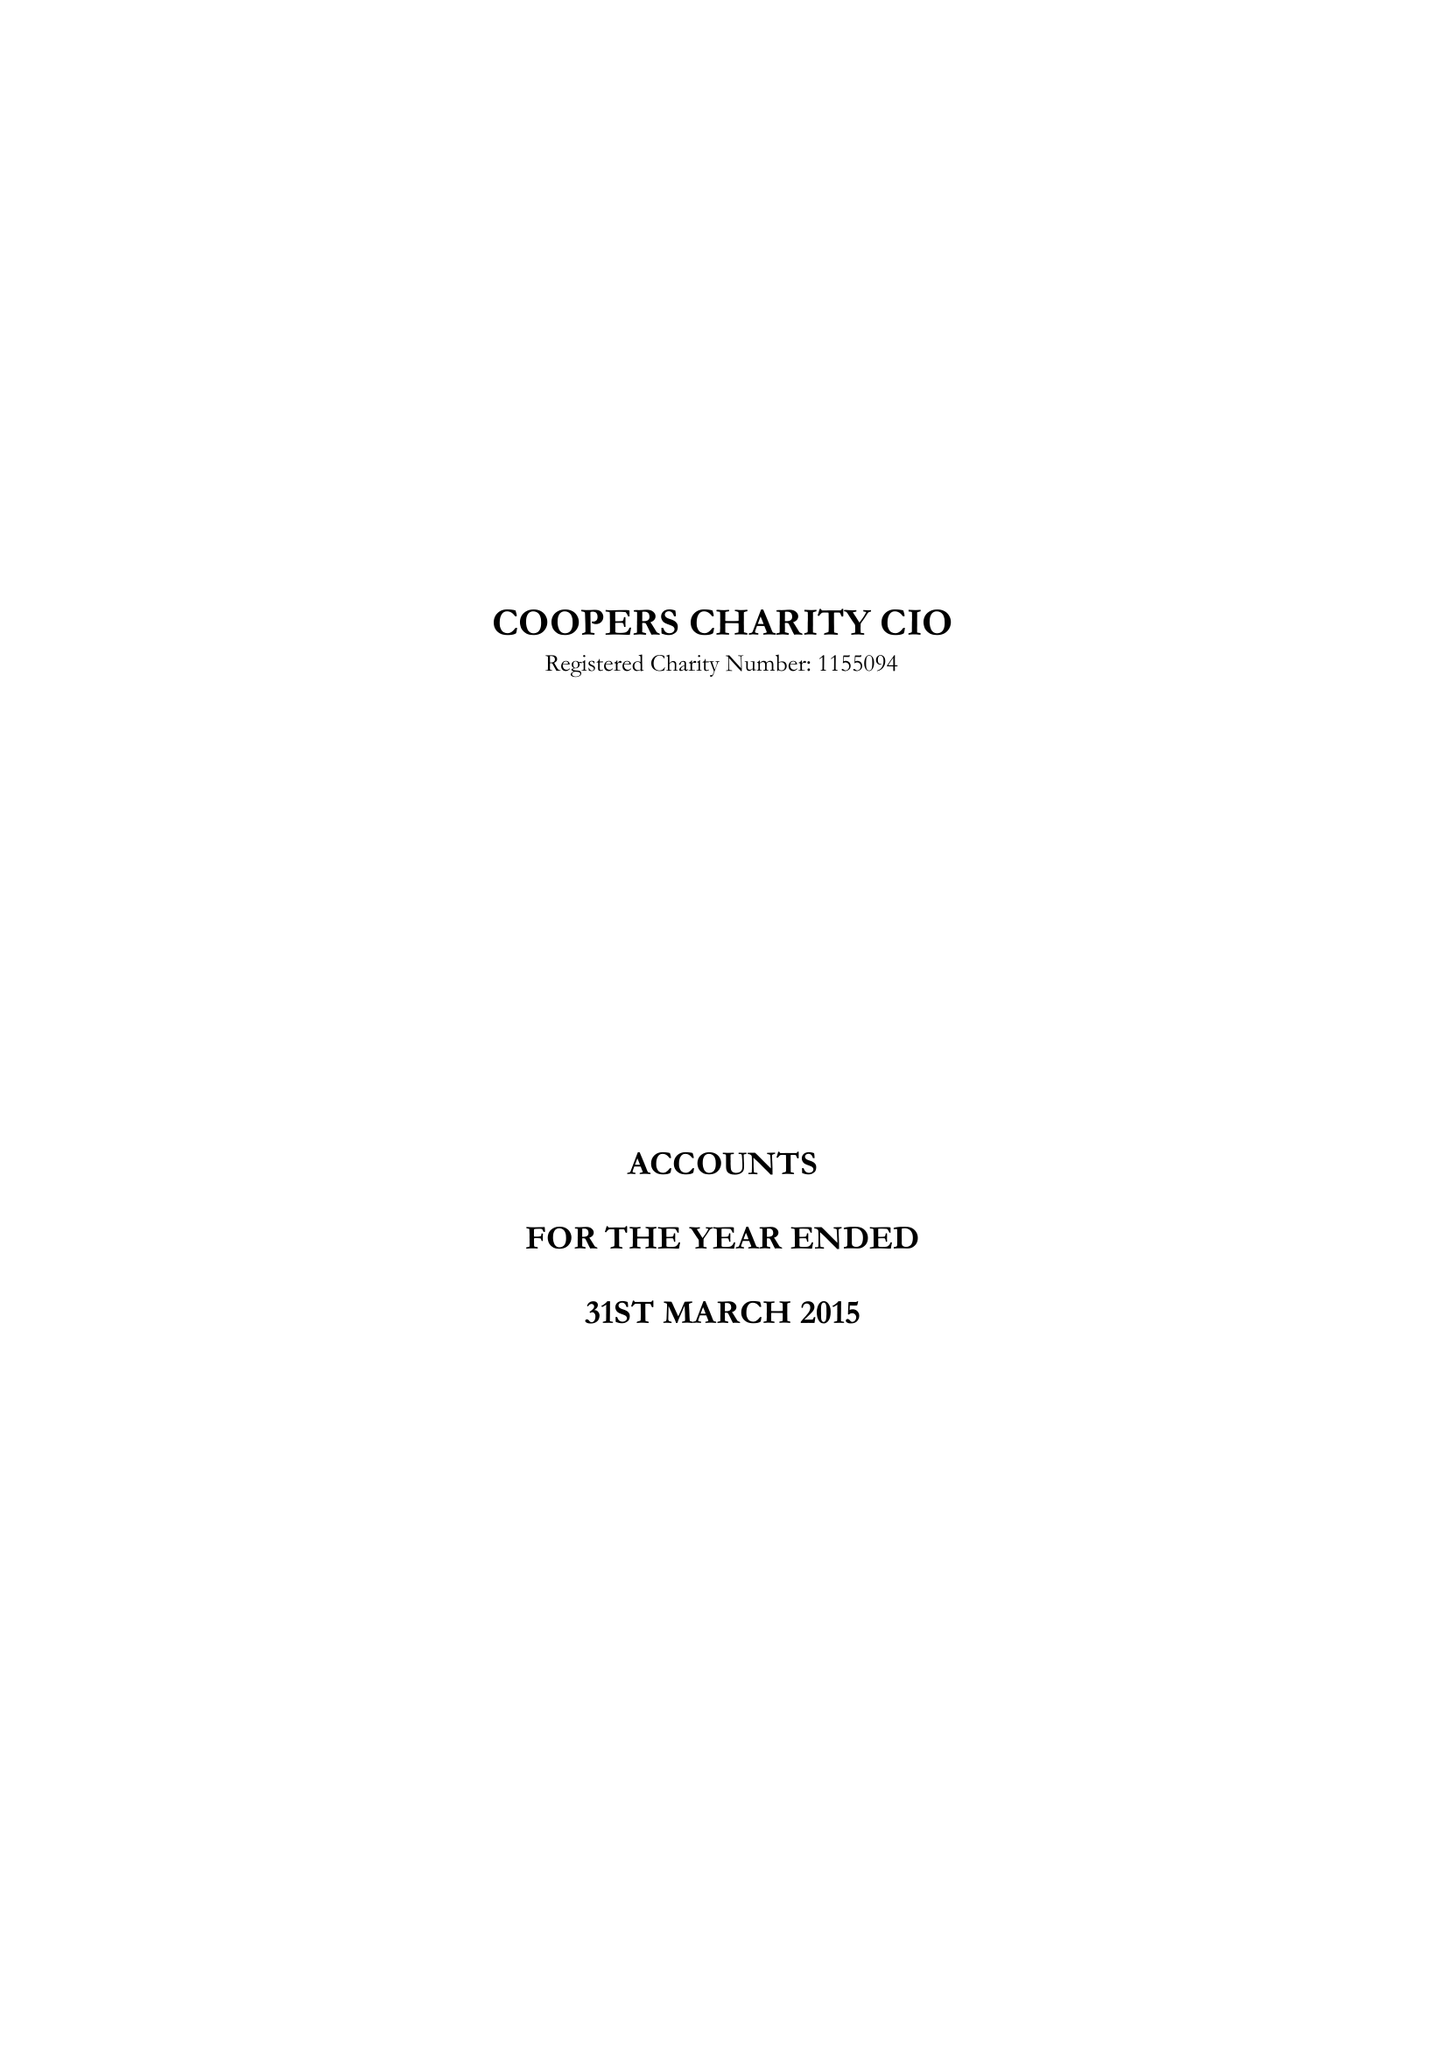What is the value for the income_annually_in_british_pounds?
Answer the question using a single word or phrase. 264042.00 